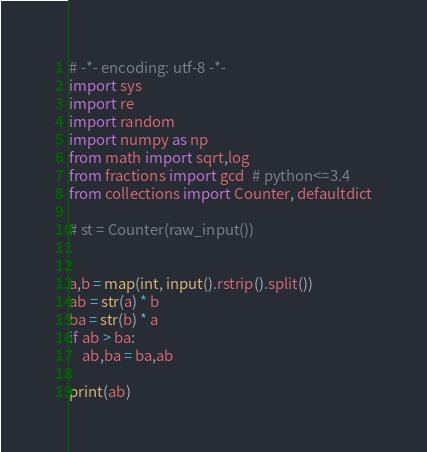Convert code to text. <code><loc_0><loc_0><loc_500><loc_500><_Python_># -*- encoding: utf-8 -*-
import sys
import re
import random
import numpy as np
from math import sqrt,log
from fractions import gcd  # python<=3.4
from collections import Counter, defaultdict

# st = Counter(raw_input())


a,b = map(int, input().rstrip().split())
ab = str(a) * b
ba = str(b) * a
if ab > ba:
    ab,ba = ba,ab

print(ab)
</code> 